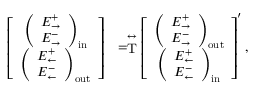Convert formula to latex. <formula><loc_0><loc_0><loc_500><loc_500>\begin{array} { r l } { \left [ \begin{array} { c } { \left ( \begin{array} { c } { E _ { \rightarrow } ^ { + } } \\ { E _ { \rightarrow } ^ { - } } \end{array} \right ) _ { i n } } \\ { \left ( \begin{array} { c } { E _ { \leftarrow } ^ { + } } \\ { E _ { \leftarrow } ^ { - } } \end{array} \right ) _ { o u t } } \end{array} \right ] } & { = \stackrel { \leftrightarrow } { T } \left [ \begin{array} { c } { \left ( \begin{array} { c } { E _ { \rightarrow } ^ { + } } \\ { E _ { \rightarrow } ^ { - } } \end{array} \right ) _ { o u t } } \\ { \left ( \begin{array} { c } { E _ { \leftarrow } ^ { + } } \\ { E _ { \leftarrow } ^ { - } } \end{array} \right ) _ { i n } } \end{array} \right ] ^ { \prime } , } \end{array}</formula> 